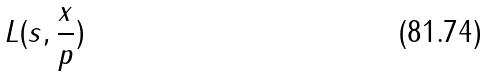<formula> <loc_0><loc_0><loc_500><loc_500>L ( s , \frac { x } { p } )</formula> 